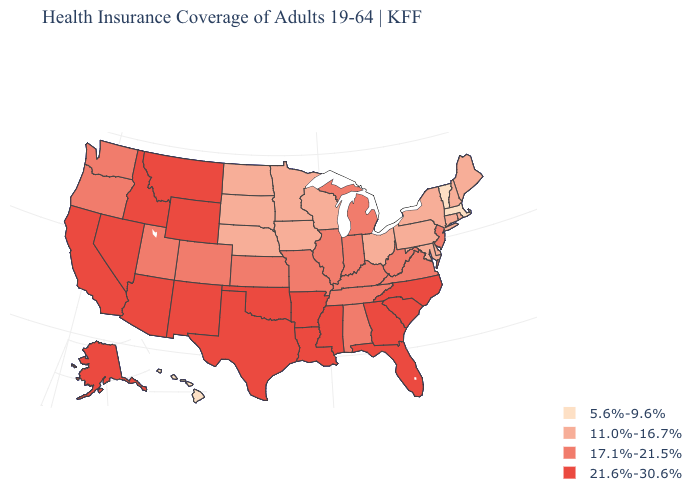What is the value of Montana?
Short answer required. 21.6%-30.6%. Does Vermont have the lowest value in the USA?
Give a very brief answer. Yes. What is the highest value in states that border Indiana?
Quick response, please. 17.1%-21.5%. What is the value of New Jersey?
Concise answer only. 17.1%-21.5%. What is the value of Nebraska?
Keep it brief. 11.0%-16.7%. What is the value of Maine?
Answer briefly. 11.0%-16.7%. Does Arizona have the same value as Indiana?
Give a very brief answer. No. Name the states that have a value in the range 21.6%-30.6%?
Short answer required. Alaska, Arizona, Arkansas, California, Florida, Georgia, Idaho, Louisiana, Mississippi, Montana, Nevada, New Mexico, North Carolina, Oklahoma, South Carolina, Texas, Wyoming. What is the value of Virginia?
Answer briefly. 17.1%-21.5%. Does Delaware have the lowest value in the South?
Short answer required. Yes. Among the states that border Tennessee , does Arkansas have the highest value?
Concise answer only. Yes. What is the highest value in states that border Oklahoma?
Concise answer only. 21.6%-30.6%. Which states have the highest value in the USA?
Be succinct. Alaska, Arizona, Arkansas, California, Florida, Georgia, Idaho, Louisiana, Mississippi, Montana, Nevada, New Mexico, North Carolina, Oklahoma, South Carolina, Texas, Wyoming. 